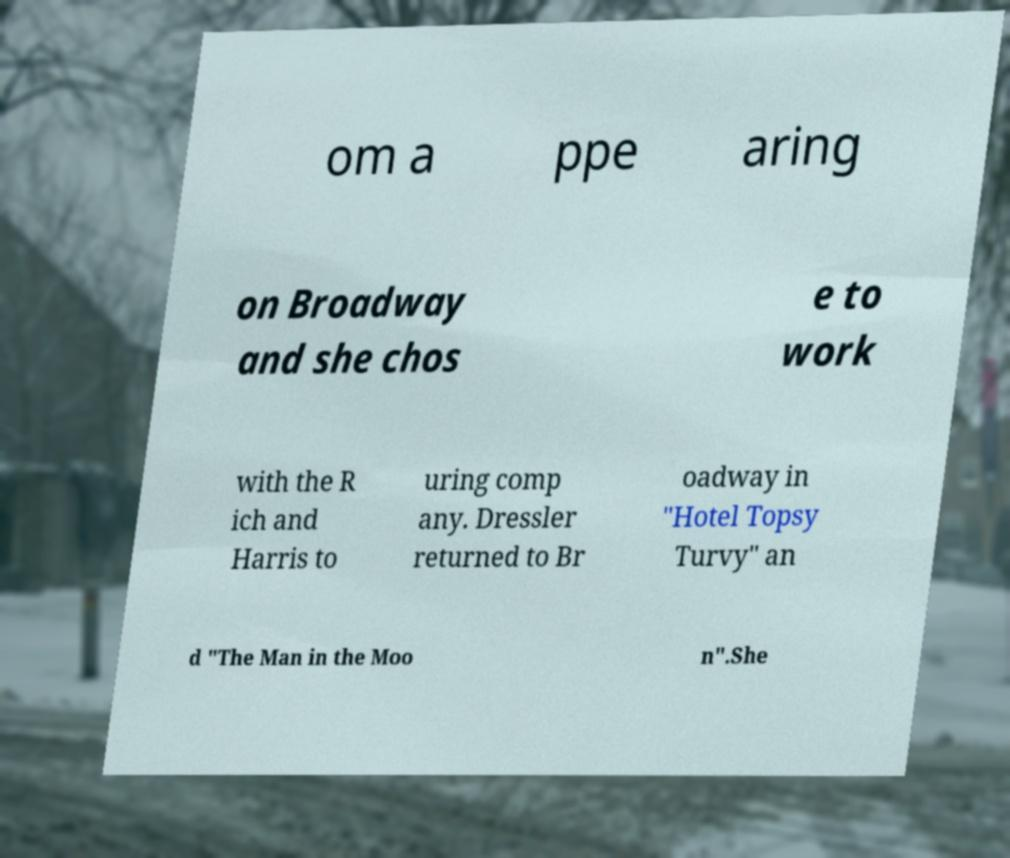Could you extract and type out the text from this image? om a ppe aring on Broadway and she chos e to work with the R ich and Harris to uring comp any. Dressler returned to Br oadway in "Hotel Topsy Turvy" an d "The Man in the Moo n".She 